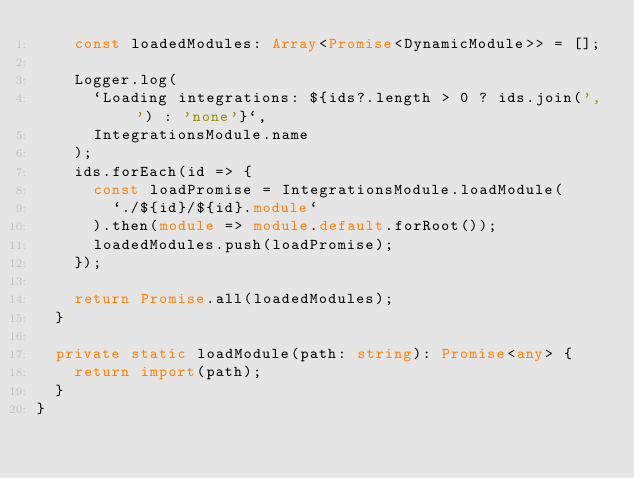Convert code to text. <code><loc_0><loc_0><loc_500><loc_500><_TypeScript_>    const loadedModules: Array<Promise<DynamicModule>> = [];

    Logger.log(
      `Loading integrations: ${ids?.length > 0 ? ids.join(', ') : 'none'}`,
      IntegrationsModule.name
    );
    ids.forEach(id => {
      const loadPromise = IntegrationsModule.loadModule(
        `./${id}/${id}.module`
      ).then(module => module.default.forRoot());
      loadedModules.push(loadPromise);
    });

    return Promise.all(loadedModules);
  }

  private static loadModule(path: string): Promise<any> {
    return import(path);
  }
}
</code> 